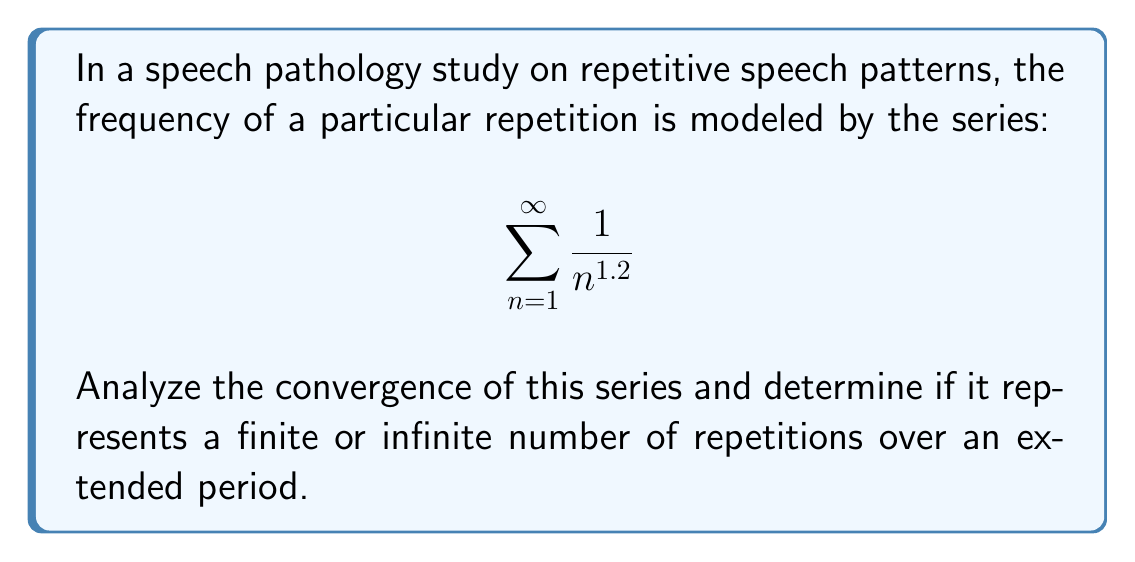Can you solve this math problem? To analyze the convergence of this series, we can use the p-series test:

1) The given series is of the form $\sum_{n=1}^{\infty} \frac{1}{n^p}$, where $p = 1.2$.

2) For a p-series:
   - If $p > 1$, the series converges.
   - If $p \leq 1$, the series diverges.

3) In this case, $p = 1.2 > 1$.

4) Therefore, the series converges.

5) To interpret this result in the context of speech patterns:
   - Convergence means the sum of all terms is finite.
   - This implies that the total number of repetitions over an extended period is finite.
   - The repetitive pattern diminishes in frequency over time, eventually becoming negligible.

6) While we can't calculate the exact sum without advanced techniques, we know it's a finite value, indicating a bounded total number of repetitions.
Answer: The series converges, representing a finite number of repetitions. 